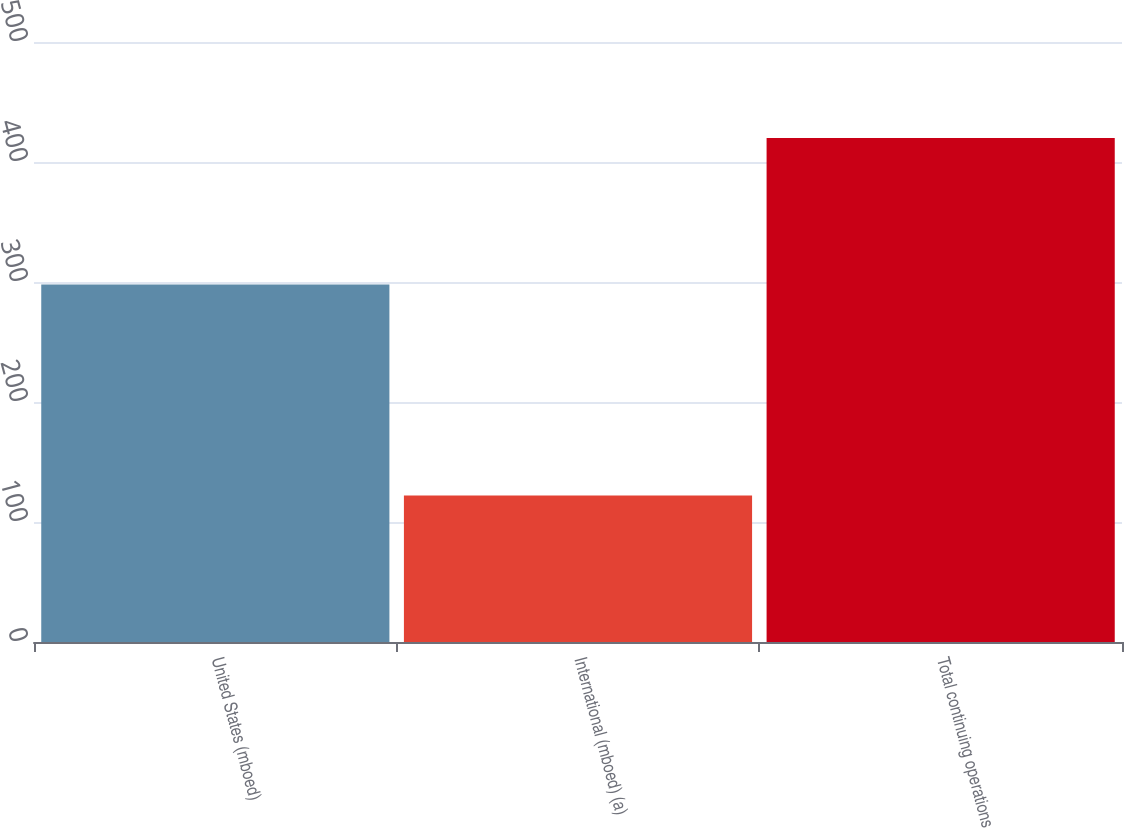Convert chart. <chart><loc_0><loc_0><loc_500><loc_500><bar_chart><fcel>United States (mboed)<fcel>International (mboed) (a)<fcel>Total continuing operations<nl><fcel>298<fcel>122<fcel>420<nl></chart> 